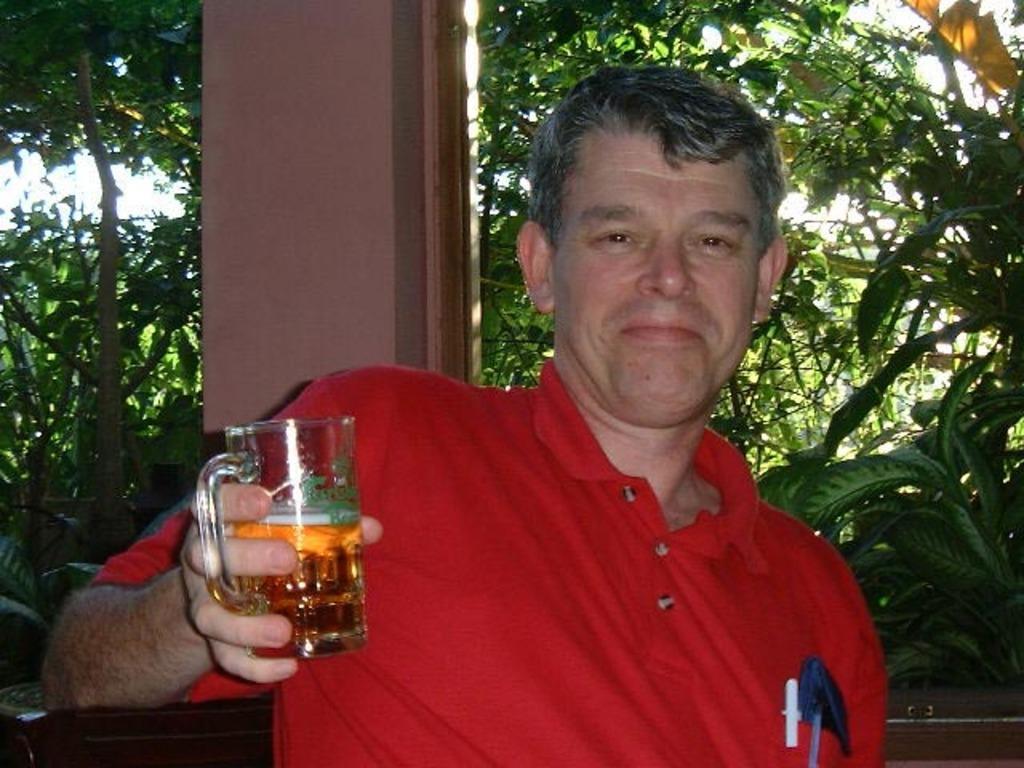Describe this image in one or two sentences. In this image i can see a person holding a wine glass. In the background i can see planets and a pillar. 